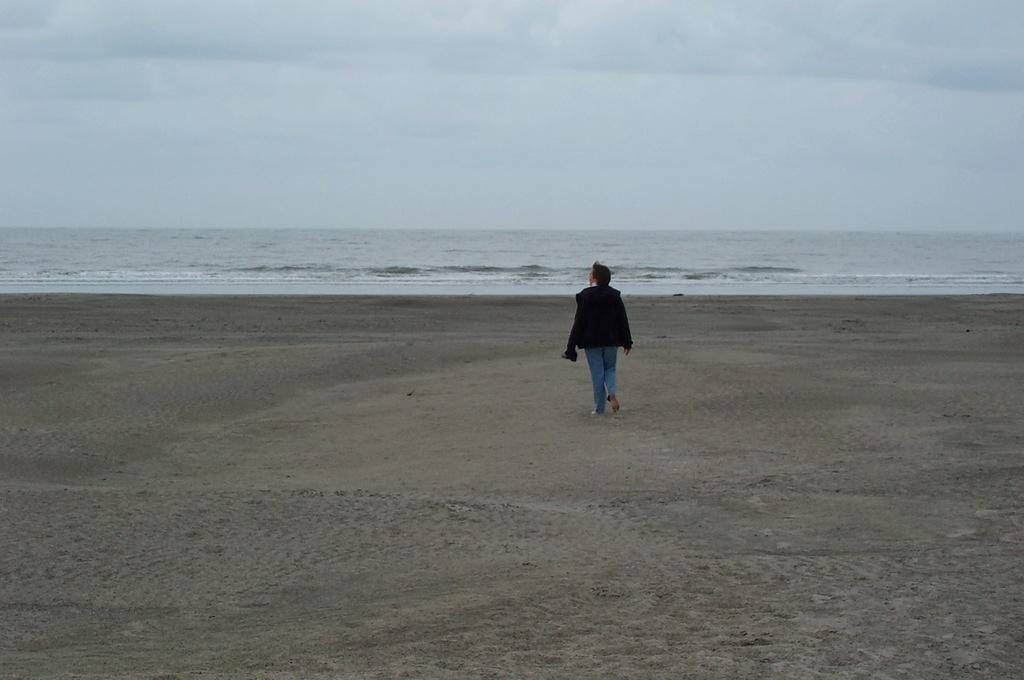What is the main subject of the image? There is a person in the image. What is the person doing in the image? The person is walking. Where is the location of the image? The location is a sea beach. What can be seen in the background of the image? There is sea and sky visible in the background of the image. What type of door can be seen in the image? There is no door present in the image; it features a person walking on a sea beach. What kind of stick is being used by the band in the image? There is no band or stick present in the image. 